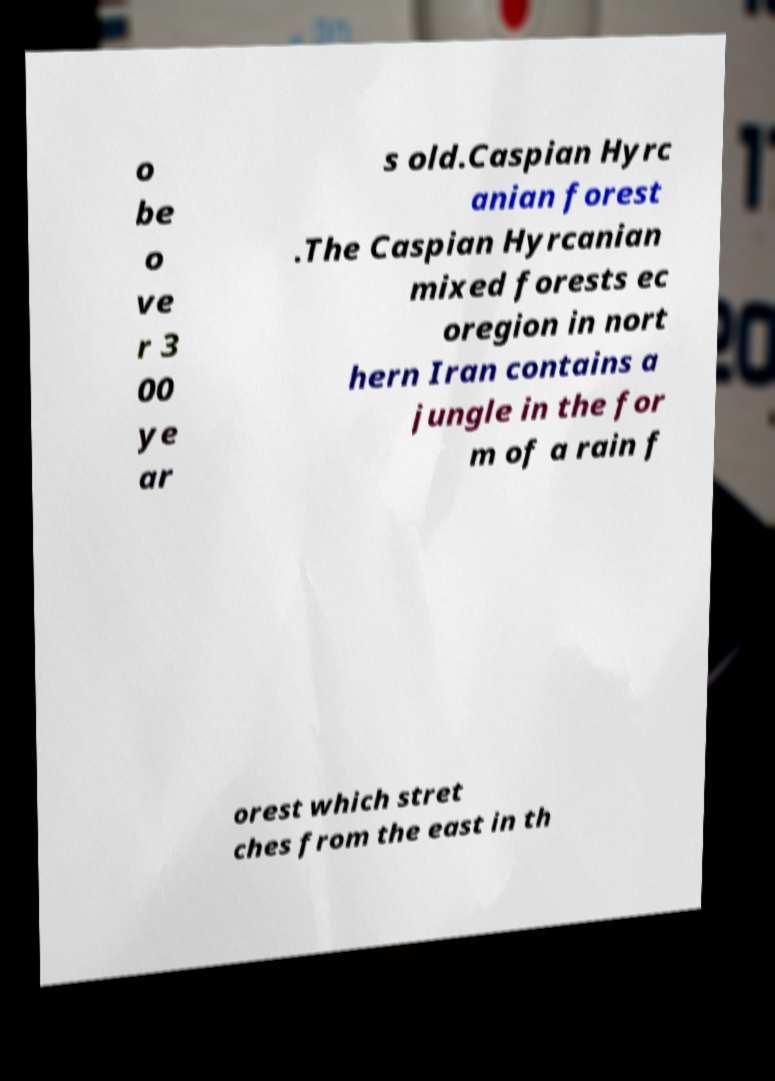For documentation purposes, I need the text within this image transcribed. Could you provide that? o be o ve r 3 00 ye ar s old.Caspian Hyrc anian forest .The Caspian Hyrcanian mixed forests ec oregion in nort hern Iran contains a jungle in the for m of a rain f orest which stret ches from the east in th 